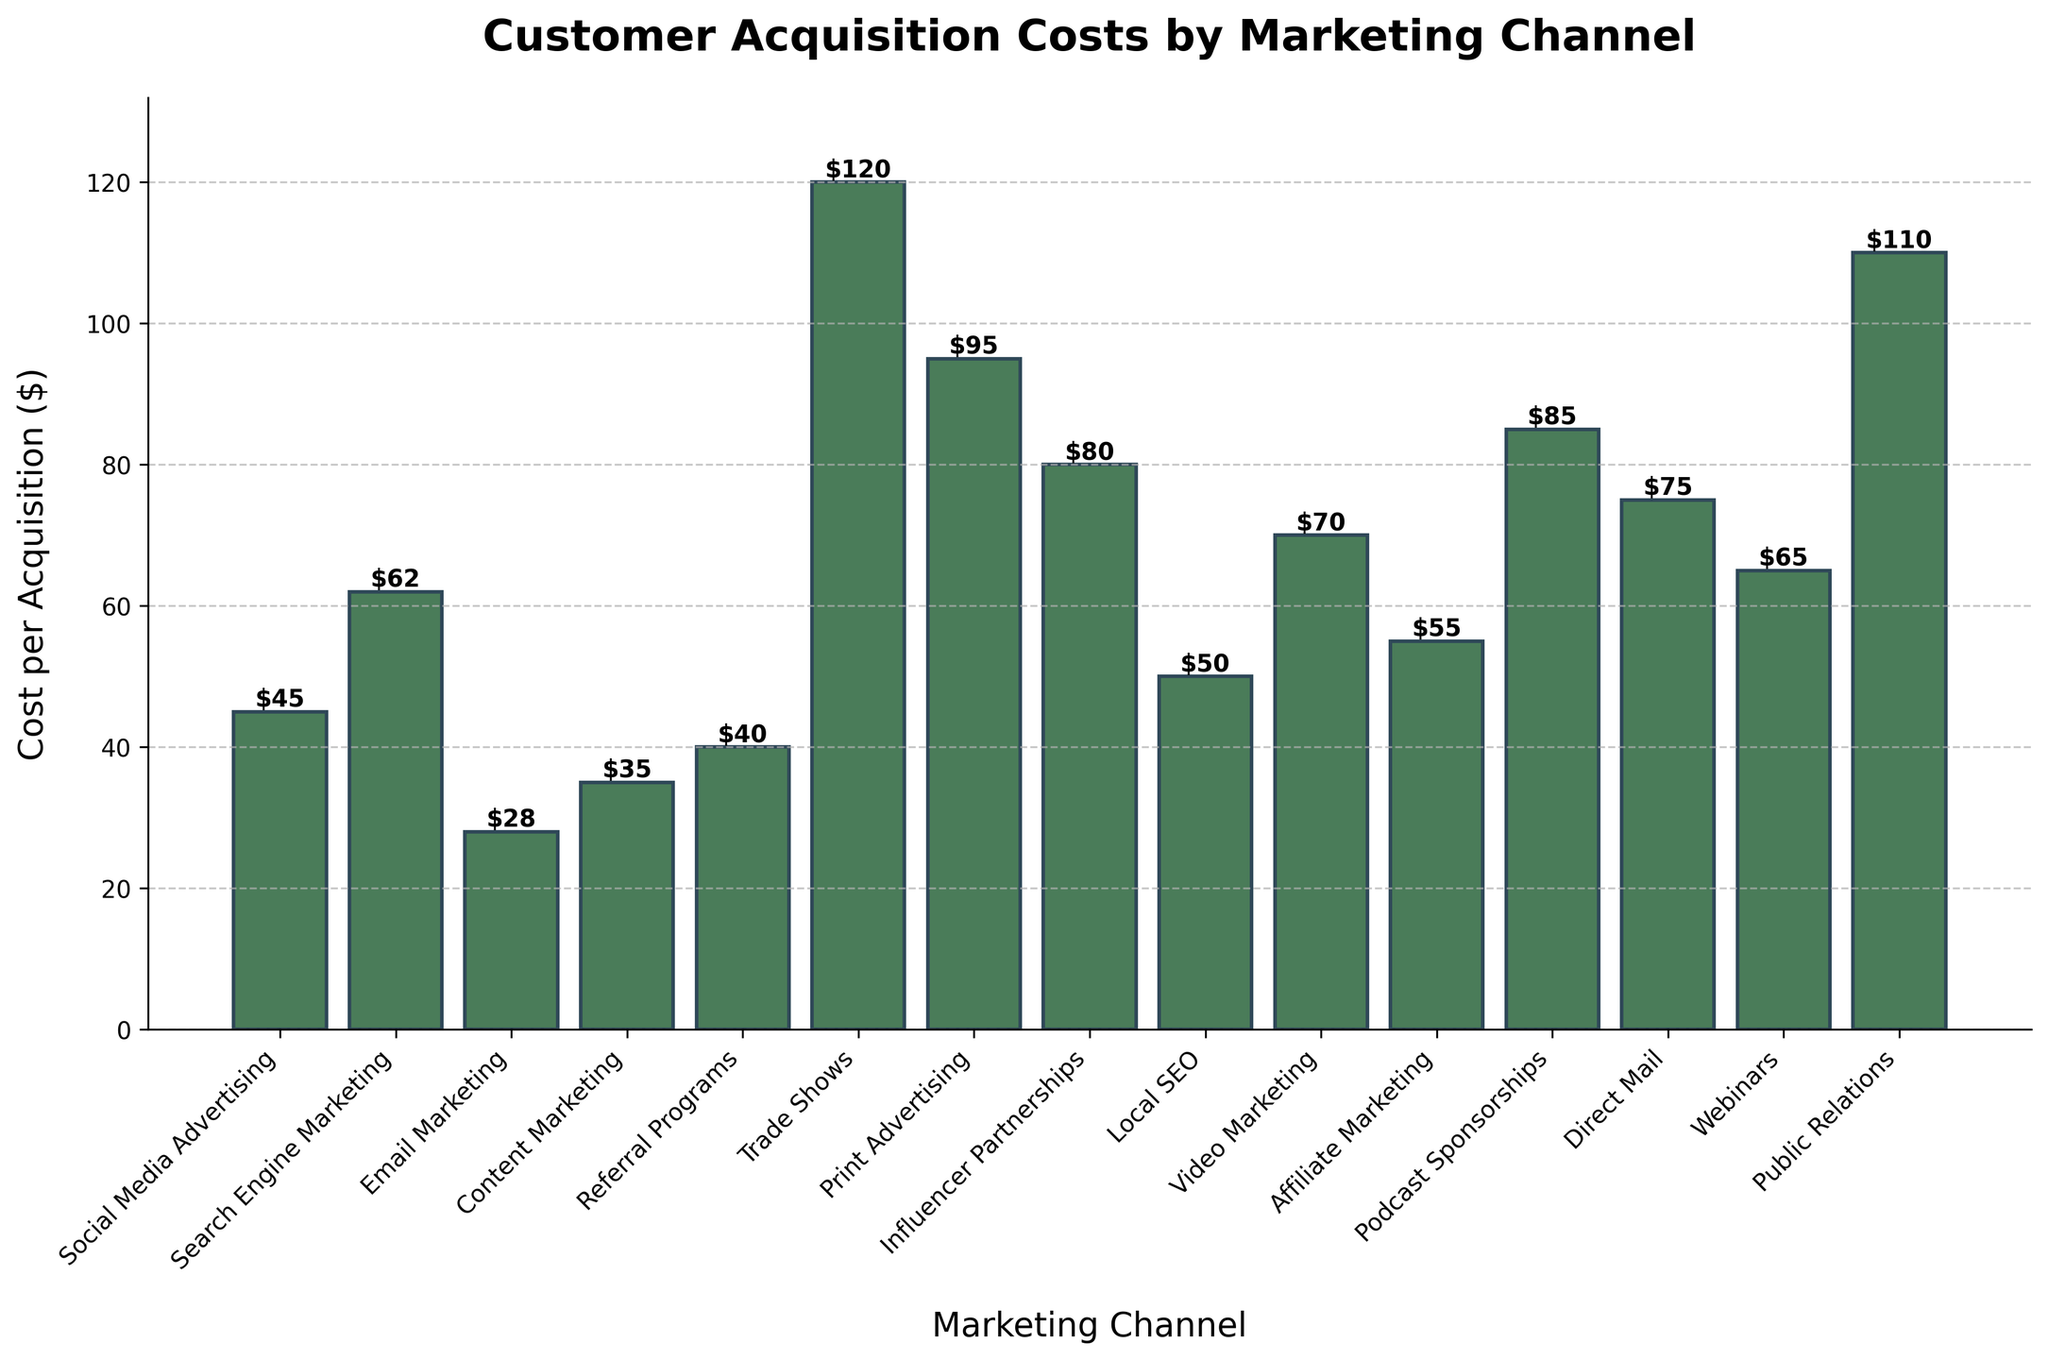Which marketing channel has the highest customer acquisition cost? To determine the marketing channel with the highest cost, look for the bar with the greatest height in the bar chart. That bar corresponds to "Trade Shows".
Answer: Trade Shows What is the difference in customer acquisition cost between Trade Shows and Email Marketing? Identify the height (value) of the bars for "Trade Shows" and "Email Marketing" from the chart. Trade Shows is $120, and Email Marketing is $28. Subtract the latter from the former: 120 - 28 = 92.
Answer: 92 Which marketing channels have customer acquisition costs less than $50? Identify the bars with heights (values) less than $50. These are "Social Media Advertising" at $45, "Email Marketing" at $28, "Content Marketing" at $35, and "Referral Programs" at $40.
Answer: Social Media Advertising, Email Marketing, Content Marketing, Referral Programs How much higher is the cost of Influencer Partnerships compared to Local SEO? Identify the heights (values) of the bars for "Influencer Partnerships" and "Local SEO". Influencer Partnerships is $80, and Local SEO is $50. Subtract the latter from the former: 80 - 50 = 30.
Answer: 30 What is the average customer acquisition cost for Email Marketing, Content Marketing, and Referral Programs? Identify the heights (values) of the bars for "Email Marketing" ($28), "Content Marketing" ($35), and "Referral Programs" ($40). Sum these values and divide by 3: (28 + 35 + 40) / 3 = 103 / 3 ≈ 34.33.
Answer: 34.33 Which marketing channel has the lowest customer acquisition cost? To determine the marketing channel with the lowest cost, look for the bar with the smallest height in the bar chart. That bar corresponds to "Email Marketing".
Answer: Email Marketing Are Webinars more costly than Video Marketing, and by how much? Identify the heights (values) of the bars for "Webinars" and "Video Marketing". Webinars is $65, and Video Marketing is $70. Subtract the former from the latter: 70 - 65 = 5. Webinars are not more costly but less by 5.
Answer: No, less by 5 Rank the following marketing channels by customer acquisition cost from lowest to highest: Public Relations, Direct Mail, Podcast Sponsorships, Influencer Partnerships. Find the heights (values) for each of these marketing channels: Public Relations ($110), Direct Mail ($75), Podcast Sponsorships ($85), Influencer Partnerships ($80). Order them from lowest to highest: Direct Mail, Influencer Partnerships, Podcast Sponsorships, Public Relations.
Answer: Direct Mail, Influencer Partnerships, Podcast Sponsorships, Public Relations What is the median customer acquisition cost for all marketing channels depicted? Arrange all customer acquisition costs in ascending order: 28, 35, 40, 45, 50, 55, 62, 65, 70, 75, 80, 85, 95, 110, 120. The median is the middle value in the ordered list. With 15 values, the middle one is the 8th one, which is $65 (Webinars).
Answer: 65 What is the total customer acquisition cost for Social Media Advertising, Search Engine Marketing, and Email Marketing? Identify the heights (values) of the bars for "Social Media Advertising" ($45), "Search Engine Marketing" ($62), and "Email Marketing" ($28). Sum these values: 45 + 62 + 28 = 135.
Answer: 135 